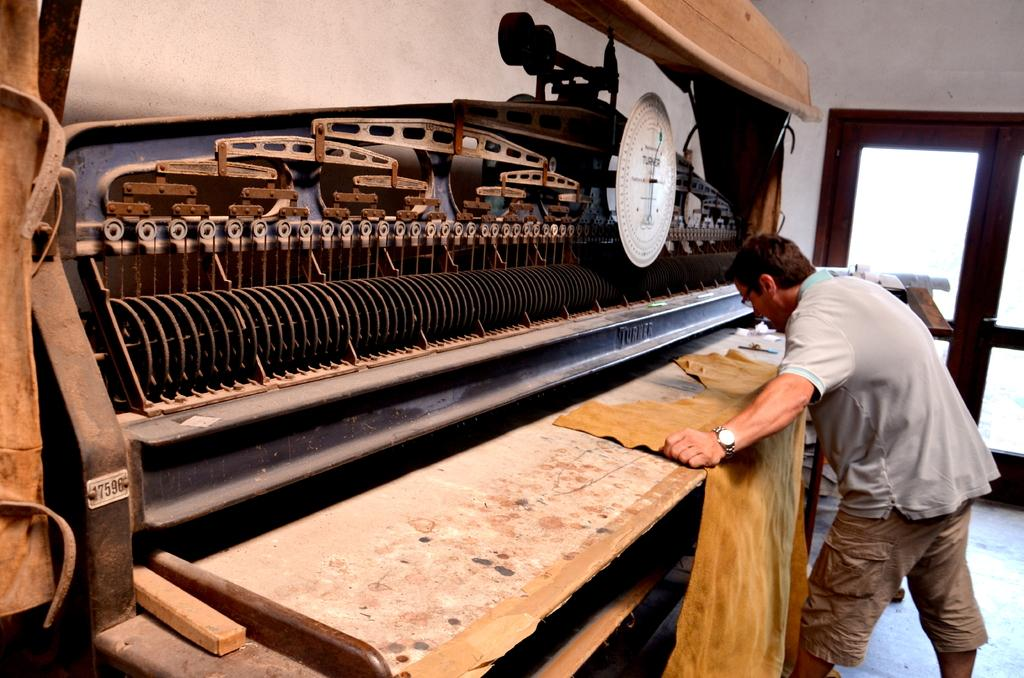What is the main subject of the image? The main subject of the image is a man standing. Can you describe the man's attire? The man is wearing clothes, a wrist watch, and spectacles. What is the man holding in his hand? The man is holding a cloth in his hand. What can be seen in the image besides the man? There is a metal object, a floor, and a window visible in the image. What type of earth can be seen through the window in the image? There is no earth visible through the window in the image; it is a window in a room. Can you describe the man's journey in the image? There is no journey depicted in the image; it simply shows a man standing with certain items and in a particular setting. 